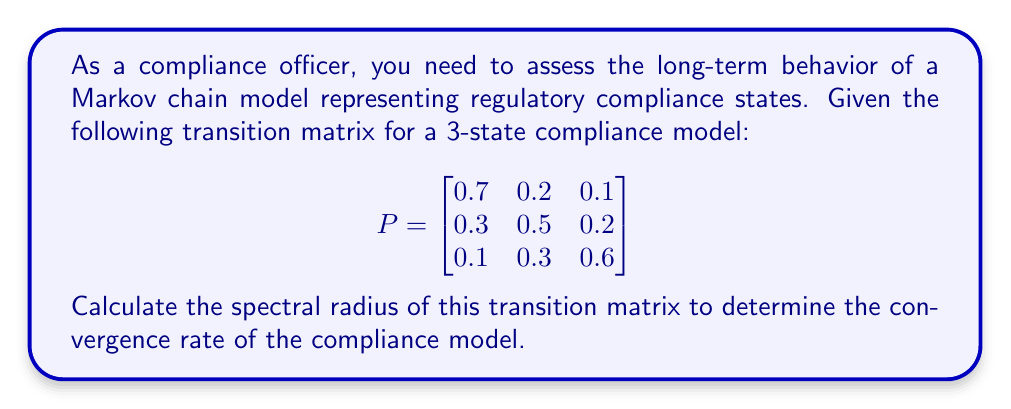What is the answer to this math problem? To calculate the spectral radius of the transition matrix, we need to follow these steps:

1. Find the characteristic equation of the matrix:
   $det(P - \lambda I) = 0$

2. Expand the determinant:
   $$\begin{vmatrix}
   0.7 - \lambda & 0.2 & 0.1 \\
   0.3 & 0.5 - \lambda & 0.2 \\
   0.1 & 0.3 & 0.6 - \lambda
   \end{vmatrix} = 0$$

3. Calculate the determinant:
   $(0.7 - \lambda)[(0.5 - \lambda)(0.6 - \lambda) - 0.06] - 0.2[0.3(0.6 - \lambda) - 0.02] + 0.1[0.3(0.5 - \lambda) - 0.06] = 0$

4. Simplify:
   $-\lambda^3 + 1.8\lambda^2 - 0.98\lambda + 0.162 = 0$

5. Solve this cubic equation to find the eigenvalues. The roots are:
   $\lambda_1 = 1$, $\lambda_2 \approx 0.5236$, $\lambda_3 \approx 0.2764$

6. The spectral radius is the largest absolute value of the eigenvalues:
   $\rho(P) = \max(|\lambda_1|, |\lambda_2|, |\lambda_3|) = 1$

The spectral radius of 1 indicates that the Markov chain is regular and will converge to a unique stationary distribution.
Answer: $\rho(P) = 1$ 